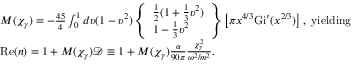<formula> <loc_0><loc_0><loc_500><loc_500>\begin{array} { l } { M ( \chi _ { \gamma } ) = - \frac { 4 5 } { 4 } \int _ { 0 } ^ { 1 } d \upsilon ( 1 - \upsilon ^ { 2 } ) \left \{ \begin{array} { l } { \frac { 1 } { 2 } ( 1 + \frac { 1 } { 3 } \upsilon ^ { 2 } ) } \\ { 1 - \frac { 1 } { 3 } \upsilon ^ { 2 } } \end{array} \right \} \left [ \pi x ^ { 4 / 3 } G i ^ { \prime } ( x ^ { 2 / 3 } ) \right ] , y i e l d i n g } \\ { R e ( n ) = 1 + M ( \chi _ { \gamma } ) \mathcal { D } \equiv 1 + M ( \chi _ { \gamma } ) \frac { \alpha } { 9 0 \pi } \frac { \chi _ { \gamma } ^ { 2 } } { \omega ^ { 2 } / m ^ { 2 } } . } \end{array}</formula> 